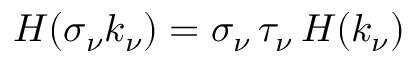Convert formula to latex. <formula><loc_0><loc_0><loc_500><loc_500>H ( \sigma _ { \nu } k _ { \nu } ) = \sigma _ { \nu } \, \tau _ { \nu } \, H ( k _ { \nu } )</formula> 